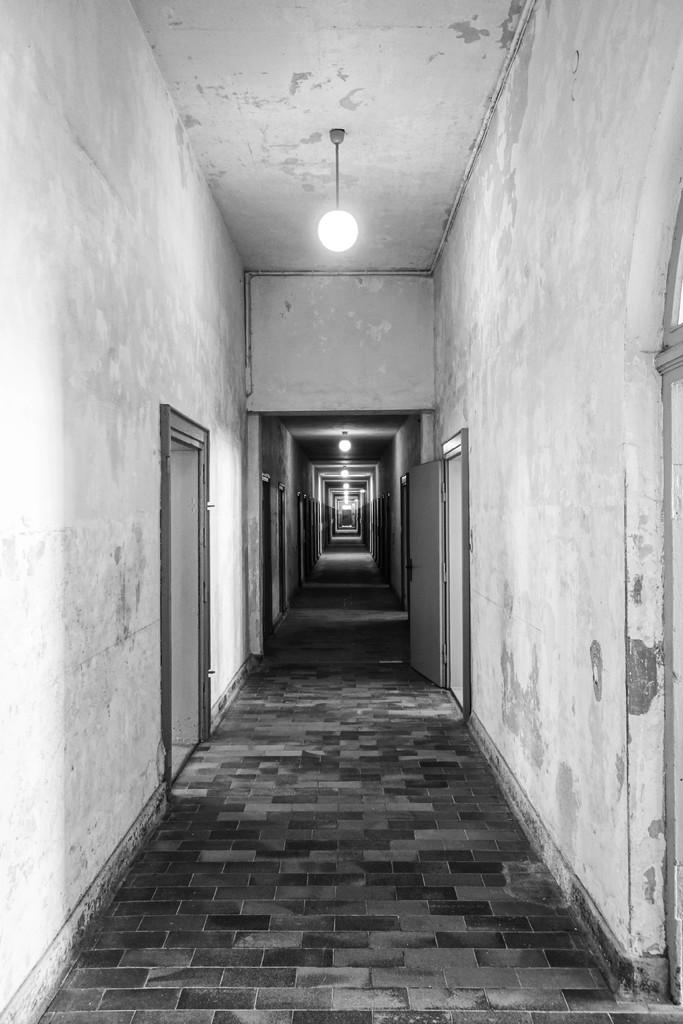What is the main structure visible in the image? There is a wall in the image. Are there any openings in the wall? Yes, there are doors on both sides of the wall. What can be seen at the top of the wall? There are lights visible at the top of the wall. What type of bridge can be seen connecting the two coasts in the image? There is no bridge or coast present in the image; it features a wall with doors and lights. 